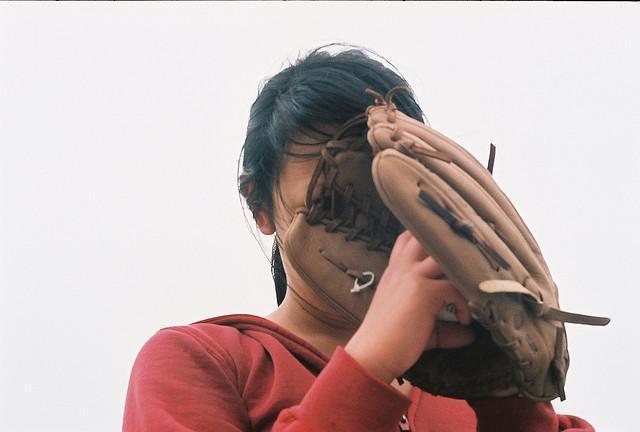How many birds are standing in the pizza box?
Give a very brief answer. 0. 